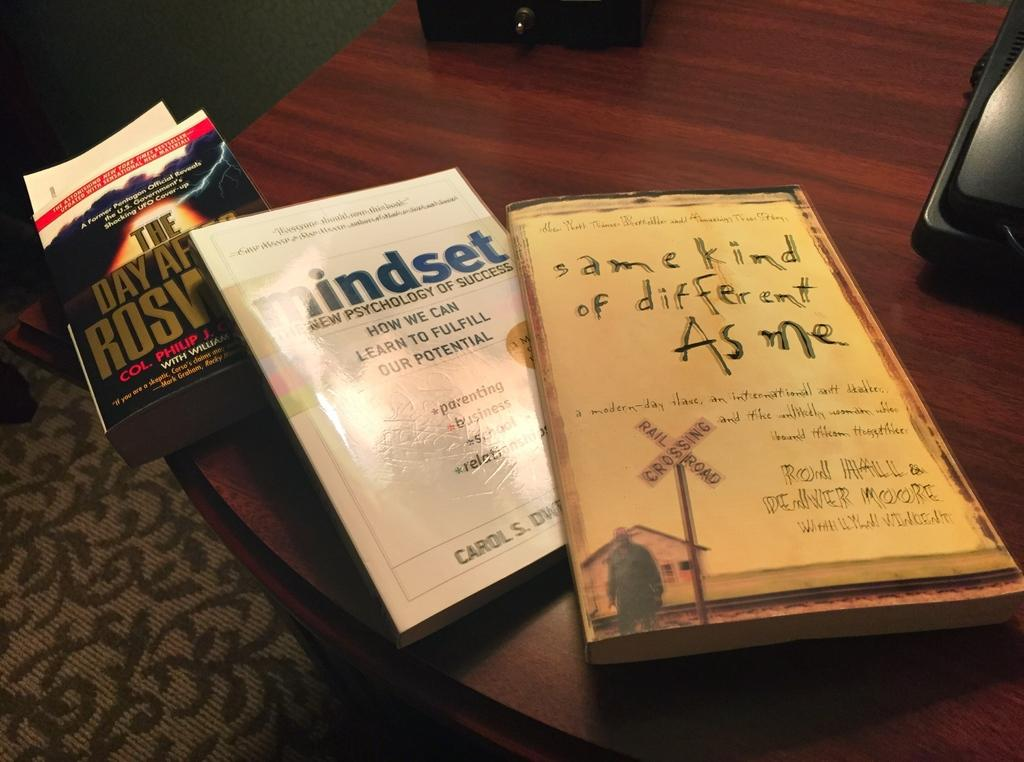Provide a one-sentence caption for the provided image. two books, one of which is called Same Kind of Different As Me. 